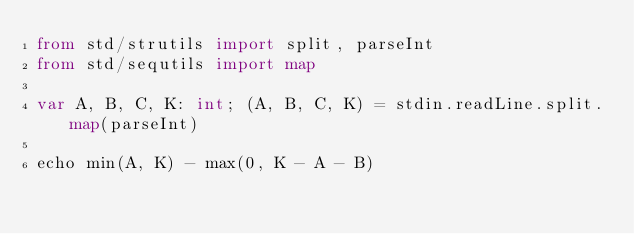<code> <loc_0><loc_0><loc_500><loc_500><_Nim_>from std/strutils import split, parseInt
from std/sequtils import map

var A, B, C, K: int; (A, B, C, K) = stdin.readLine.split.map(parseInt)

echo min(A, K) - max(0, K - A - B)
</code> 